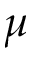Convert formula to latex. <formula><loc_0><loc_0><loc_500><loc_500>\mu</formula> 